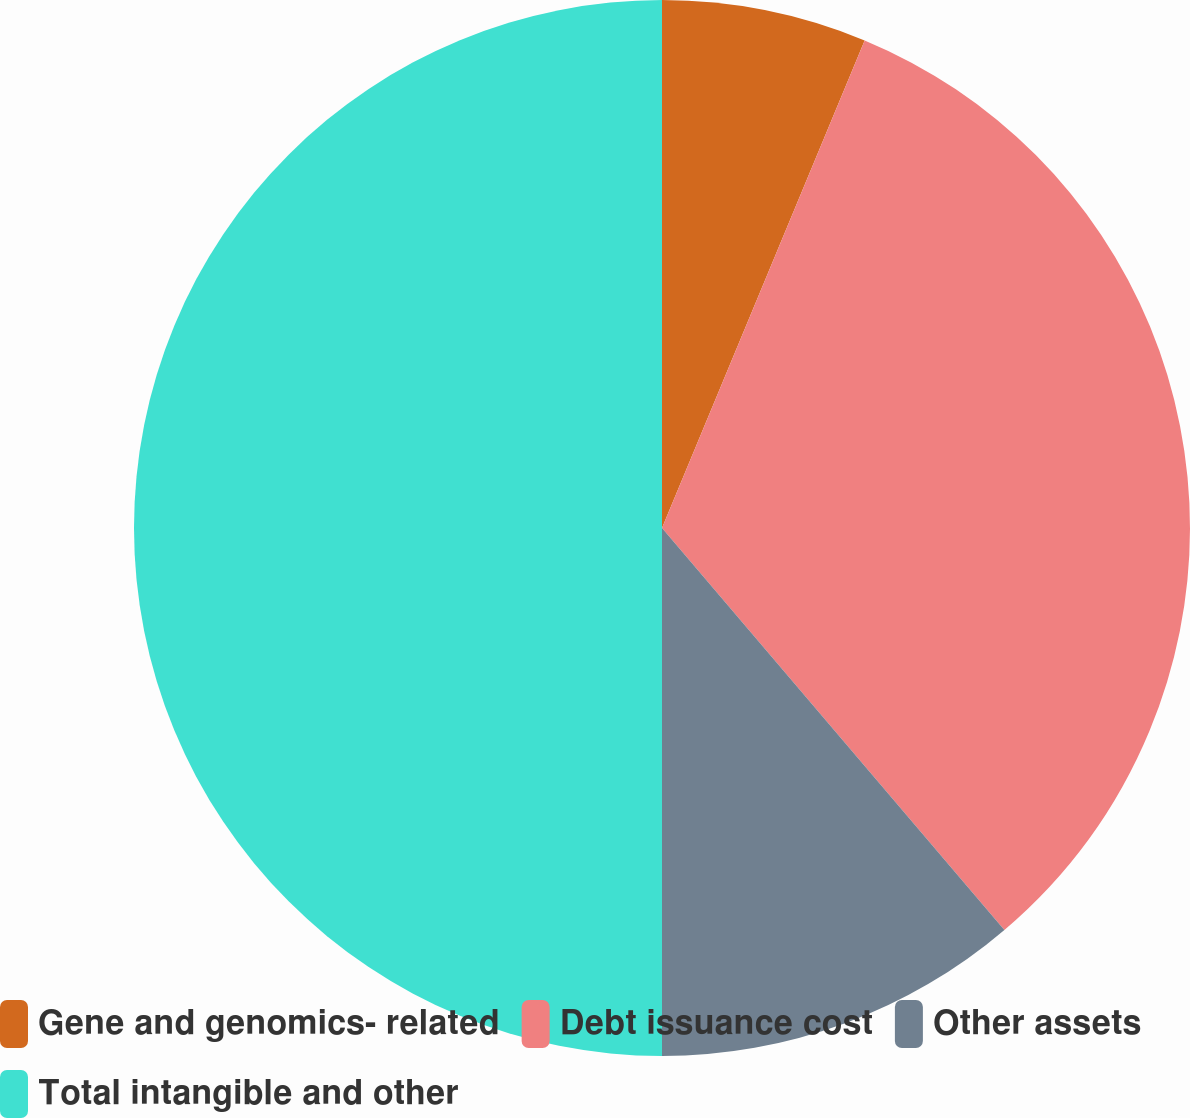<chart> <loc_0><loc_0><loc_500><loc_500><pie_chart><fcel>Gene and genomics- related<fcel>Debt issuance cost<fcel>Other assets<fcel>Total intangible and other<nl><fcel>6.27%<fcel>32.5%<fcel>11.23%<fcel>50.0%<nl></chart> 